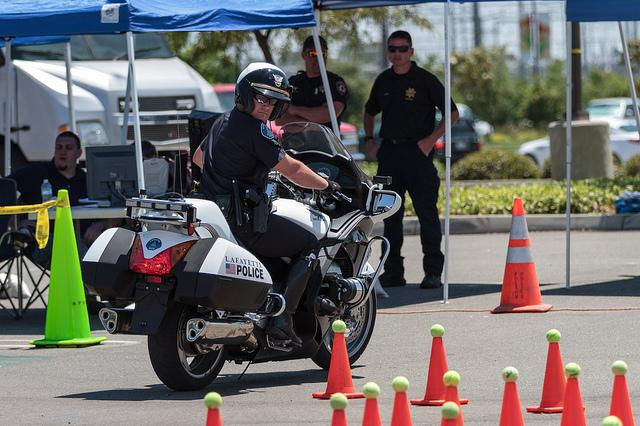What locale does the policeman serve? lafayette 